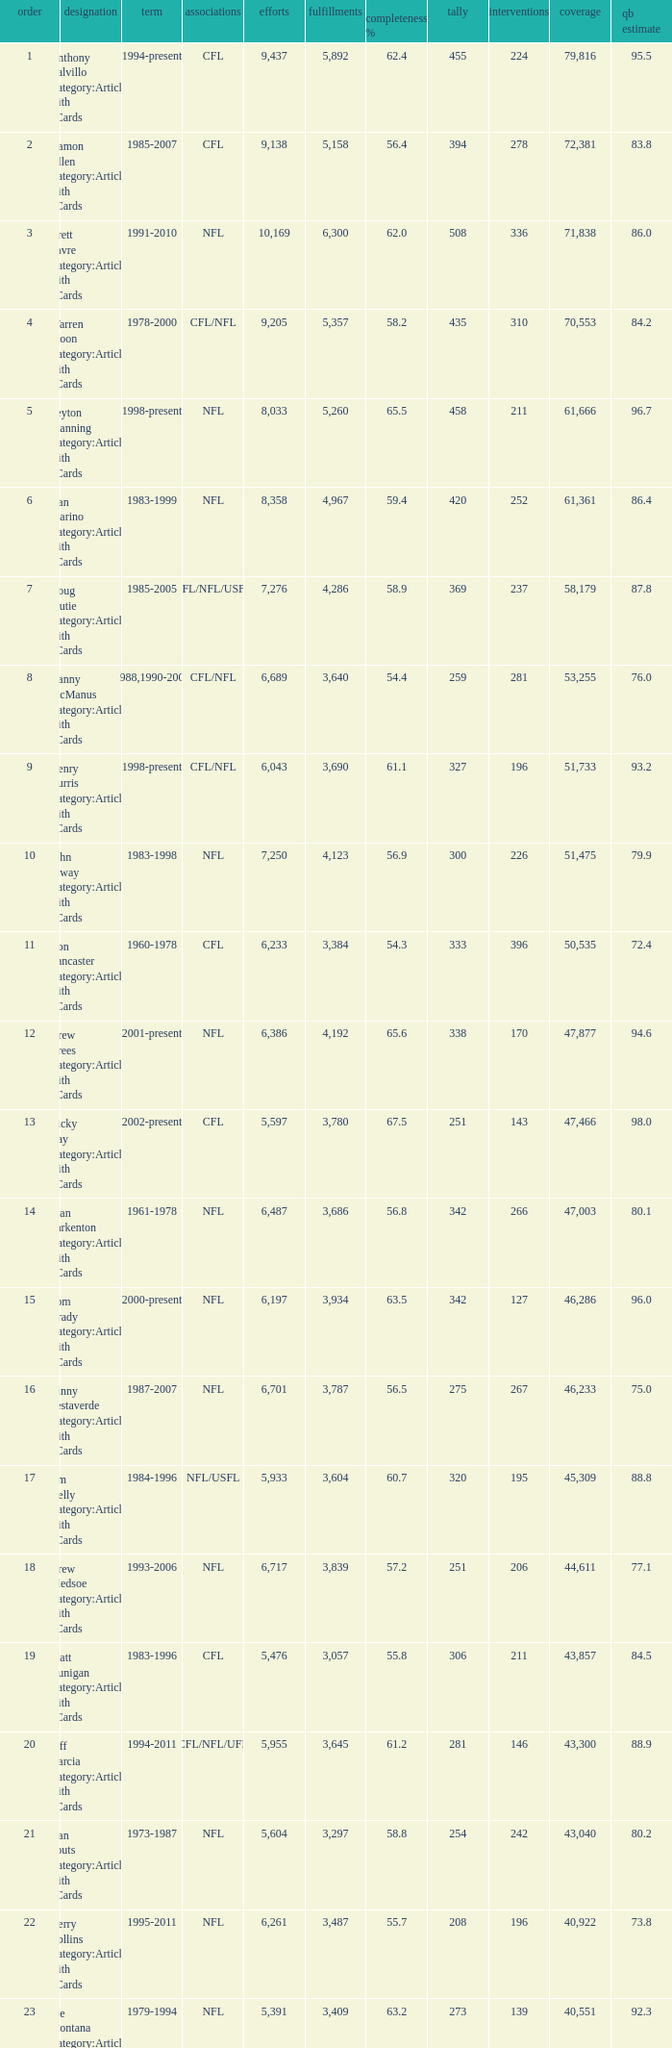What is the comp percentage when there are less than 44,611 in yardage, more than 254 touchdowns, and rank larger than 24? 54.6. 